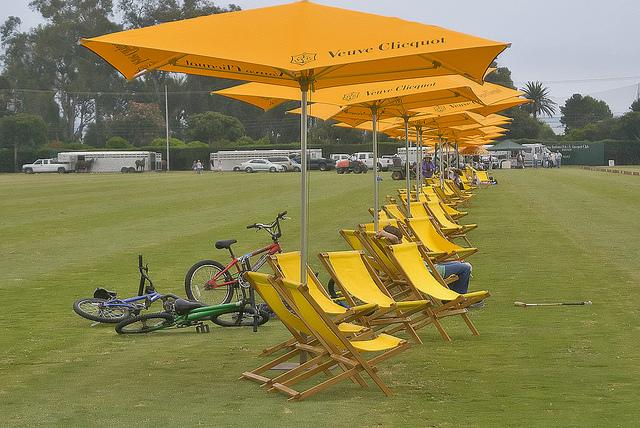The sporting event taking place on the grounds is most likely which one? Please explain your reasoning. golf. There are clubs on the grass. 